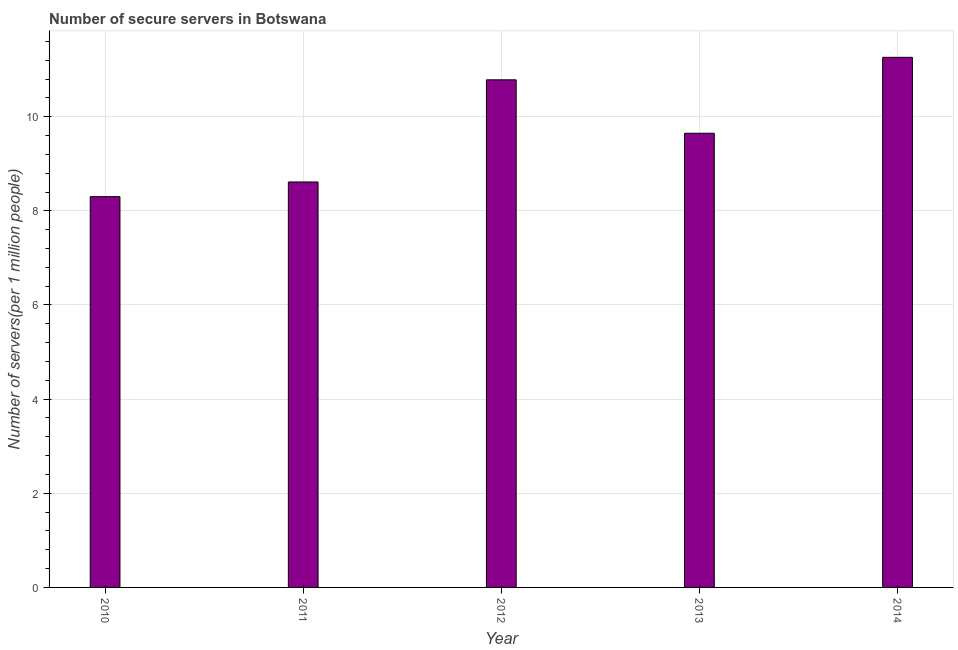Does the graph contain grids?
Ensure brevity in your answer.  Yes. What is the title of the graph?
Your answer should be very brief. Number of secure servers in Botswana. What is the label or title of the Y-axis?
Provide a short and direct response. Number of servers(per 1 million people). What is the number of secure internet servers in 2012?
Your answer should be compact. 10.78. Across all years, what is the maximum number of secure internet servers?
Provide a succinct answer. 11.26. Across all years, what is the minimum number of secure internet servers?
Provide a short and direct response. 8.3. In which year was the number of secure internet servers maximum?
Give a very brief answer. 2014. What is the sum of the number of secure internet servers?
Give a very brief answer. 48.61. What is the difference between the number of secure internet servers in 2010 and 2014?
Make the answer very short. -2.96. What is the average number of secure internet servers per year?
Give a very brief answer. 9.72. What is the median number of secure internet servers?
Your response must be concise. 9.65. In how many years, is the number of secure internet servers greater than 8 ?
Make the answer very short. 5. What is the ratio of the number of secure internet servers in 2010 to that in 2013?
Provide a succinct answer. 0.86. Is the difference between the number of secure internet servers in 2011 and 2012 greater than the difference between any two years?
Provide a succinct answer. No. What is the difference between the highest and the second highest number of secure internet servers?
Make the answer very short. 0.48. What is the difference between the highest and the lowest number of secure internet servers?
Offer a terse response. 2.96. In how many years, is the number of secure internet servers greater than the average number of secure internet servers taken over all years?
Keep it short and to the point. 2. How many years are there in the graph?
Your answer should be compact. 5. What is the Number of servers(per 1 million people) in 2010?
Your answer should be very brief. 8.3. What is the Number of servers(per 1 million people) of 2011?
Give a very brief answer. 8.61. What is the Number of servers(per 1 million people) in 2012?
Offer a very short reply. 10.78. What is the Number of servers(per 1 million people) in 2013?
Provide a succinct answer. 9.65. What is the Number of servers(per 1 million people) in 2014?
Your answer should be very brief. 11.26. What is the difference between the Number of servers(per 1 million people) in 2010 and 2011?
Offer a terse response. -0.31. What is the difference between the Number of servers(per 1 million people) in 2010 and 2012?
Provide a succinct answer. -2.48. What is the difference between the Number of servers(per 1 million people) in 2010 and 2013?
Keep it short and to the point. -1.35. What is the difference between the Number of servers(per 1 million people) in 2010 and 2014?
Keep it short and to the point. -2.96. What is the difference between the Number of servers(per 1 million people) in 2011 and 2012?
Keep it short and to the point. -2.17. What is the difference between the Number of servers(per 1 million people) in 2011 and 2013?
Your answer should be very brief. -1.03. What is the difference between the Number of servers(per 1 million people) in 2011 and 2014?
Provide a succinct answer. -2.65. What is the difference between the Number of servers(per 1 million people) in 2012 and 2013?
Provide a succinct answer. 1.14. What is the difference between the Number of servers(per 1 million people) in 2012 and 2014?
Offer a terse response. -0.48. What is the difference between the Number of servers(per 1 million people) in 2013 and 2014?
Offer a terse response. -1.61. What is the ratio of the Number of servers(per 1 million people) in 2010 to that in 2011?
Your response must be concise. 0.96. What is the ratio of the Number of servers(per 1 million people) in 2010 to that in 2012?
Provide a succinct answer. 0.77. What is the ratio of the Number of servers(per 1 million people) in 2010 to that in 2013?
Offer a terse response. 0.86. What is the ratio of the Number of servers(per 1 million people) in 2010 to that in 2014?
Offer a terse response. 0.74. What is the ratio of the Number of servers(per 1 million people) in 2011 to that in 2012?
Your answer should be very brief. 0.8. What is the ratio of the Number of servers(per 1 million people) in 2011 to that in 2013?
Provide a short and direct response. 0.89. What is the ratio of the Number of servers(per 1 million people) in 2011 to that in 2014?
Make the answer very short. 0.77. What is the ratio of the Number of servers(per 1 million people) in 2012 to that in 2013?
Ensure brevity in your answer.  1.12. What is the ratio of the Number of servers(per 1 million people) in 2012 to that in 2014?
Provide a short and direct response. 0.96. What is the ratio of the Number of servers(per 1 million people) in 2013 to that in 2014?
Keep it short and to the point. 0.86. 